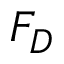<formula> <loc_0><loc_0><loc_500><loc_500>F _ { D }</formula> 